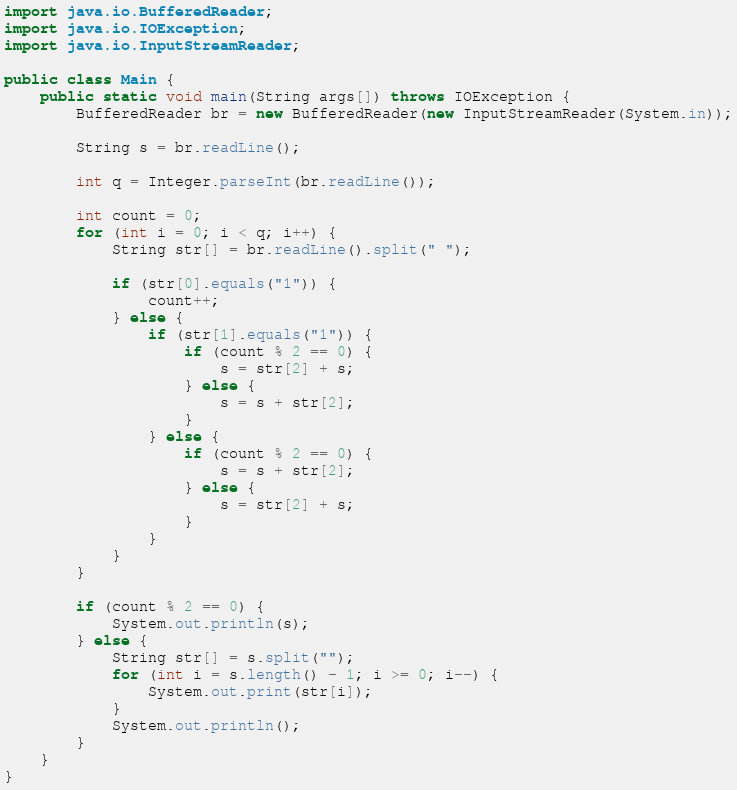Convert code to text. <code><loc_0><loc_0><loc_500><loc_500><_Java_>import java.io.BufferedReader;
import java.io.IOException;
import java.io.InputStreamReader;

public class Main {
	public static void main(String args[]) throws IOException {
		BufferedReader br = new BufferedReader(new InputStreamReader(System.in));

		String s = br.readLine();

		int q = Integer.parseInt(br.readLine());

		int count = 0;
		for (int i = 0; i < q; i++) {
			String str[] = br.readLine().split(" ");

			if (str[0].equals("1")) {
				count++;
			} else {
				if (str[1].equals("1")) {
					if (count % 2 == 0) {
						s = str[2] + s;
					} else {
						s = s + str[2];
					}
				} else {
					if (count % 2 == 0) {
						s = s + str[2];
					} else {
						s = str[2] + s;
					}
				}
			}
		}

		if (count % 2 == 0) {
			System.out.println(s);
		} else {
			String str[] = s.split("");
			for (int i = s.length() - 1; i >= 0; i--) {
				System.out.print(str[i]);
			}
			System.out.println();
		}
	}
}
</code> 